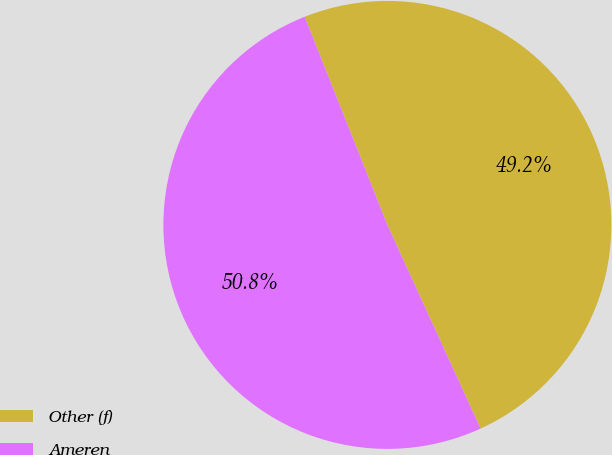Convert chart. <chart><loc_0><loc_0><loc_500><loc_500><pie_chart><fcel>Other (f)<fcel>Ameren<nl><fcel>49.19%<fcel>50.81%<nl></chart> 